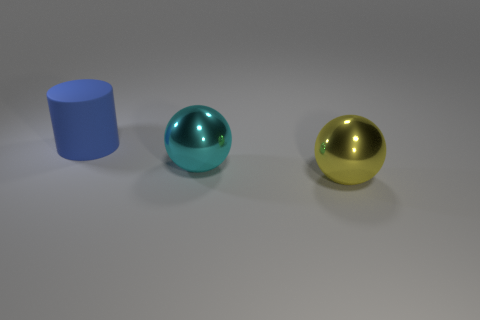Add 3 cyan shiny balls. How many objects exist? 6 Subtract all cylinders. How many objects are left? 2 Subtract all large green metal things. Subtract all large cylinders. How many objects are left? 2 Add 2 big rubber cylinders. How many big rubber cylinders are left? 3 Add 3 metallic objects. How many metallic objects exist? 5 Subtract 0 cyan blocks. How many objects are left? 3 